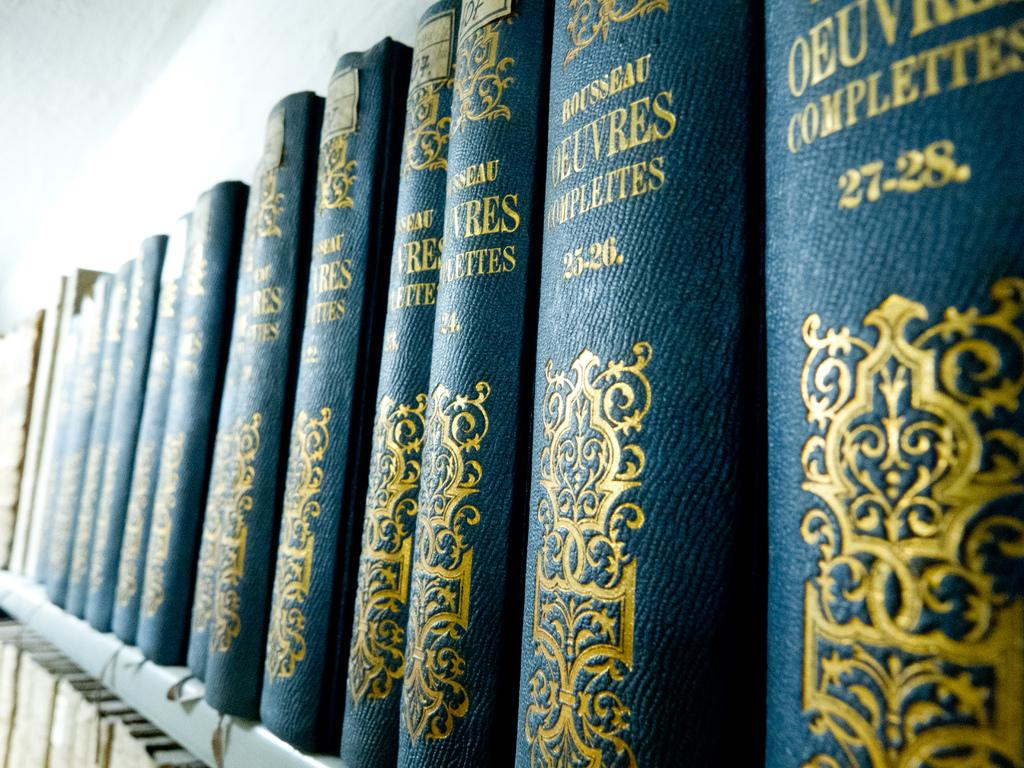Provide a one-sentence caption for the provided image. Many volumes of Rousseau Oeuvres Complettes are on a shelf. 